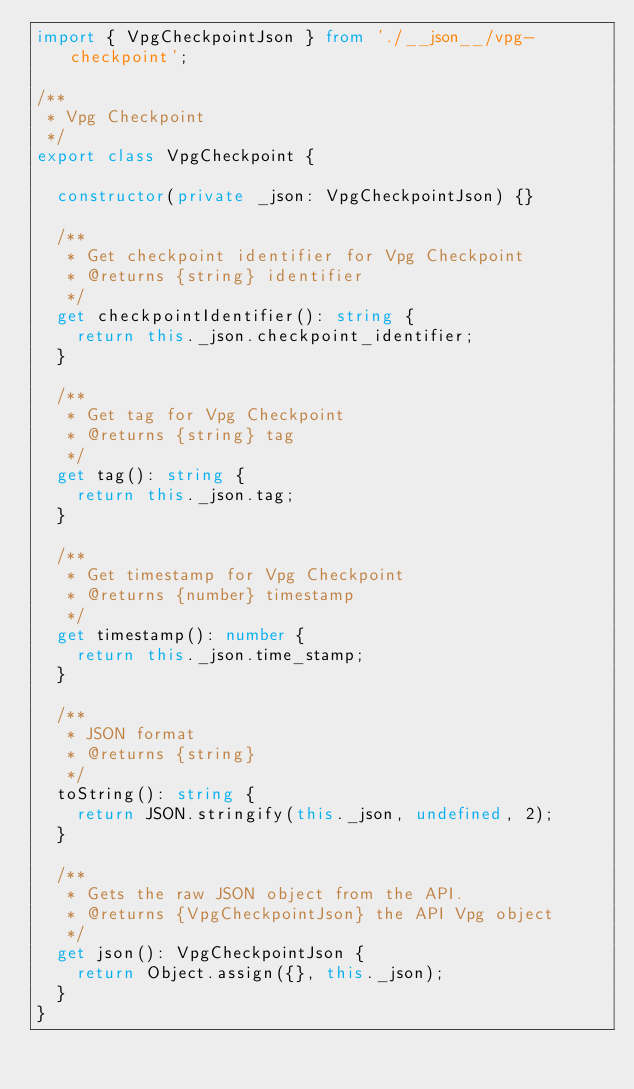<code> <loc_0><loc_0><loc_500><loc_500><_TypeScript_>import { VpgCheckpointJson } from './__json__/vpg-checkpoint';

/**
 * Vpg Checkpoint
 */
export class VpgCheckpoint {

  constructor(private _json: VpgCheckpointJson) {}

  /**
   * Get checkpoint identifier for Vpg Checkpoint
   * @returns {string} identifier
   */
  get checkpointIdentifier(): string {
    return this._json.checkpoint_identifier;
  }

  /**
   * Get tag for Vpg Checkpoint
   * @returns {string} tag
   */
  get tag(): string {
    return this._json.tag;
  }

  /**
   * Get timestamp for Vpg Checkpoint
   * @returns {number} timestamp
   */
  get timestamp(): number {
    return this._json.time_stamp;
  }

  /**
   * JSON format
   * @returns {string}
   */
  toString(): string {
    return JSON.stringify(this._json, undefined, 2);
  }

  /**
   * Gets the raw JSON object from the API.
   * @returns {VpgCheckpointJson} the API Vpg object
   */
  get json(): VpgCheckpointJson {
    return Object.assign({}, this._json);
  }
}
</code> 